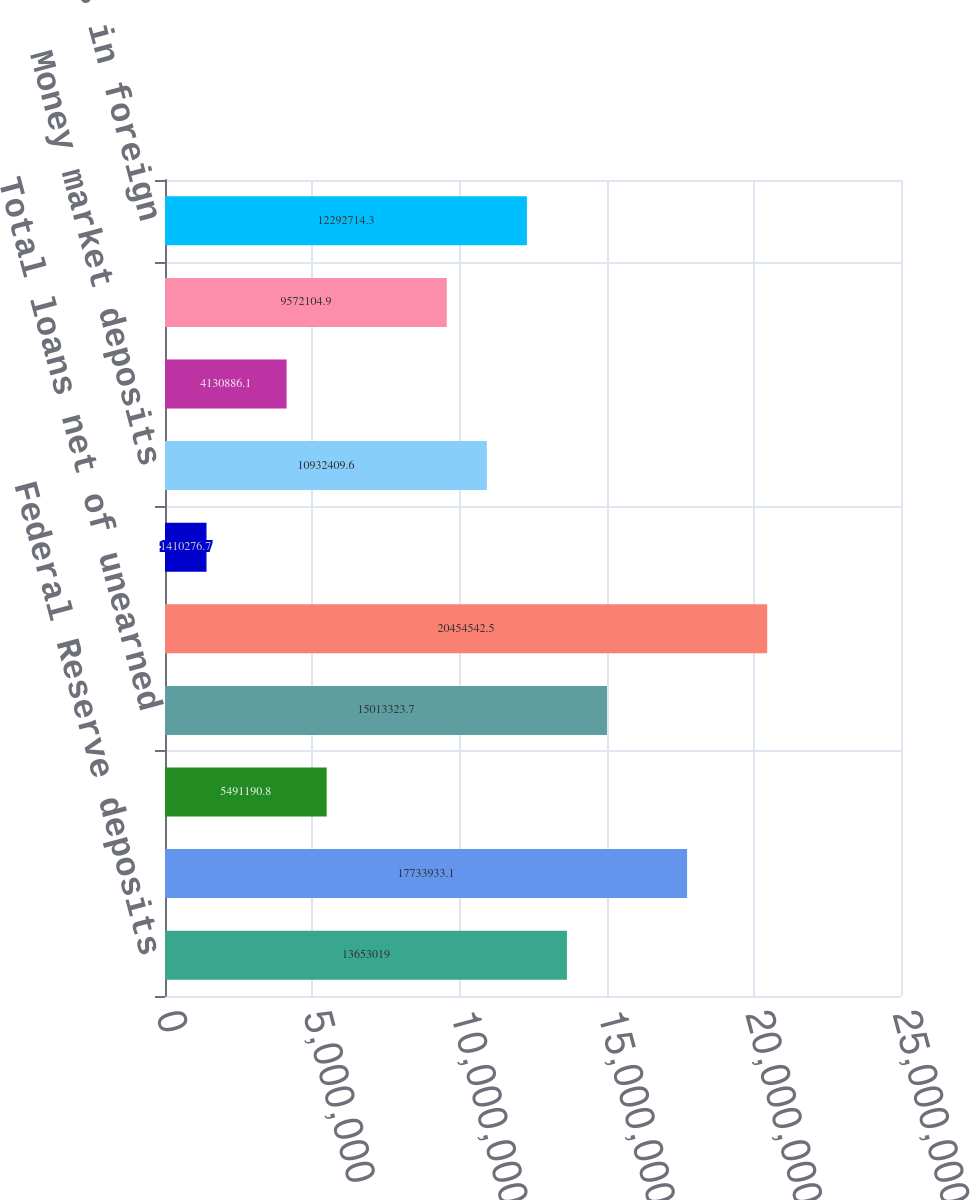Convert chart. <chart><loc_0><loc_0><loc_500><loc_500><bar_chart><fcel>Federal Reserve deposits<fcel>Taxable<fcel>Non-taxable (3)<fcel>Total loans net of unearned<fcel>Total interest-earning assets<fcel>NOW deposits<fcel>Money market deposits<fcel>Money market deposits in<fcel>Time deposits<fcel>Sweep deposits in foreign<nl><fcel>1.3653e+07<fcel>1.77339e+07<fcel>5.49119e+06<fcel>1.50133e+07<fcel>2.04545e+07<fcel>1.41028e+06<fcel>1.09324e+07<fcel>4.13089e+06<fcel>9.5721e+06<fcel>1.22927e+07<nl></chart> 